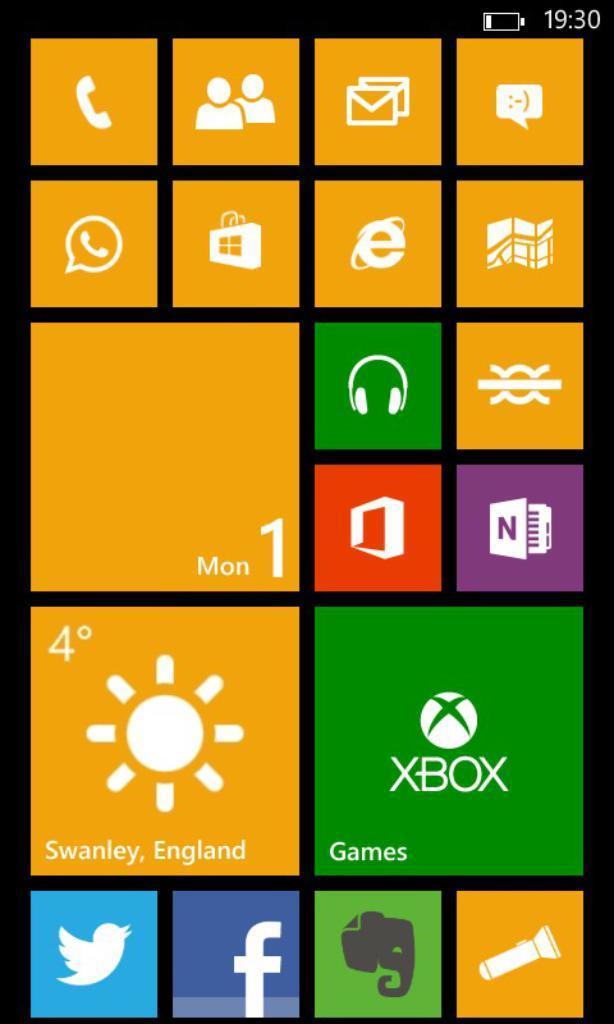Describe this image in one or two sentences. It is a screen shot of a mobile home page and it is displaying the menu of all the applications in a mobile phone. 